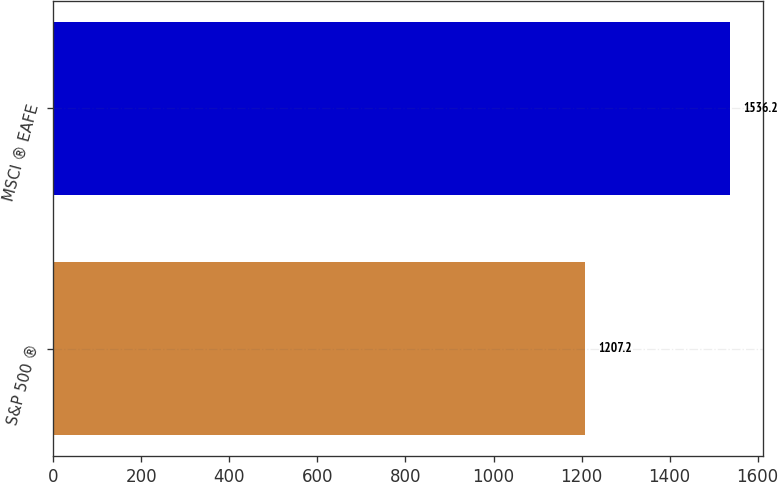<chart> <loc_0><loc_0><loc_500><loc_500><bar_chart><fcel>S&P 500 ®<fcel>MSCI ® EAFE<nl><fcel>1207.2<fcel>1536.2<nl></chart> 